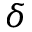Convert formula to latex. <formula><loc_0><loc_0><loc_500><loc_500>\delta</formula> 